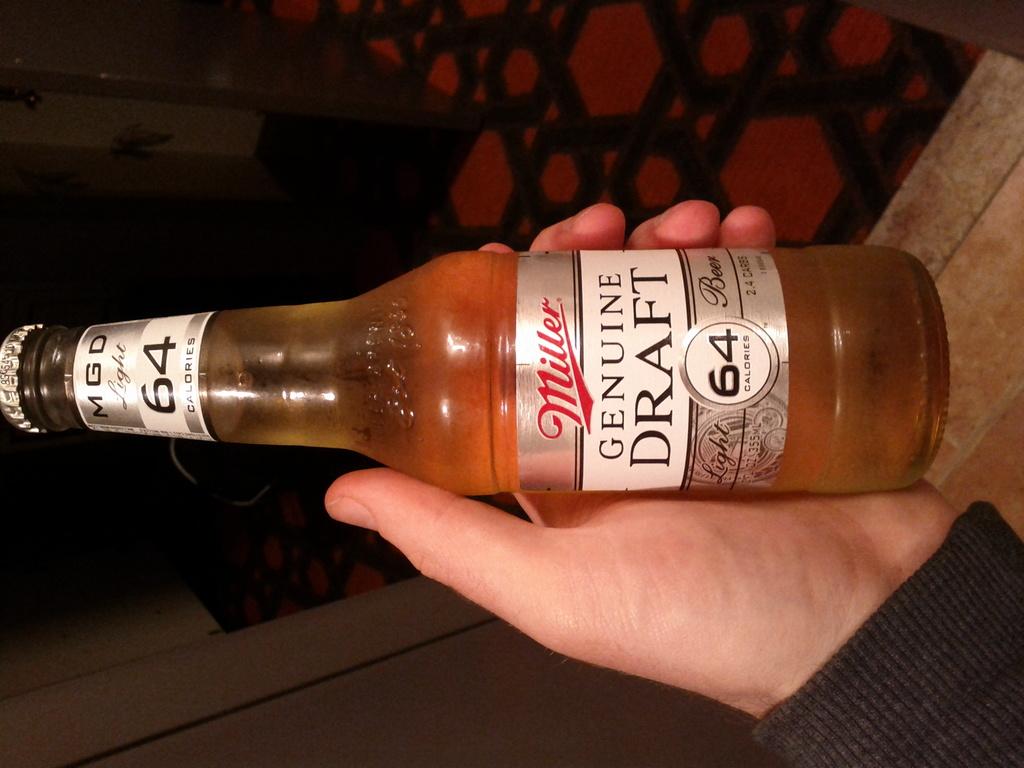What kind of beer is this?
Your answer should be very brief. Miller. How many calories in this beer?
Make the answer very short. 64. 